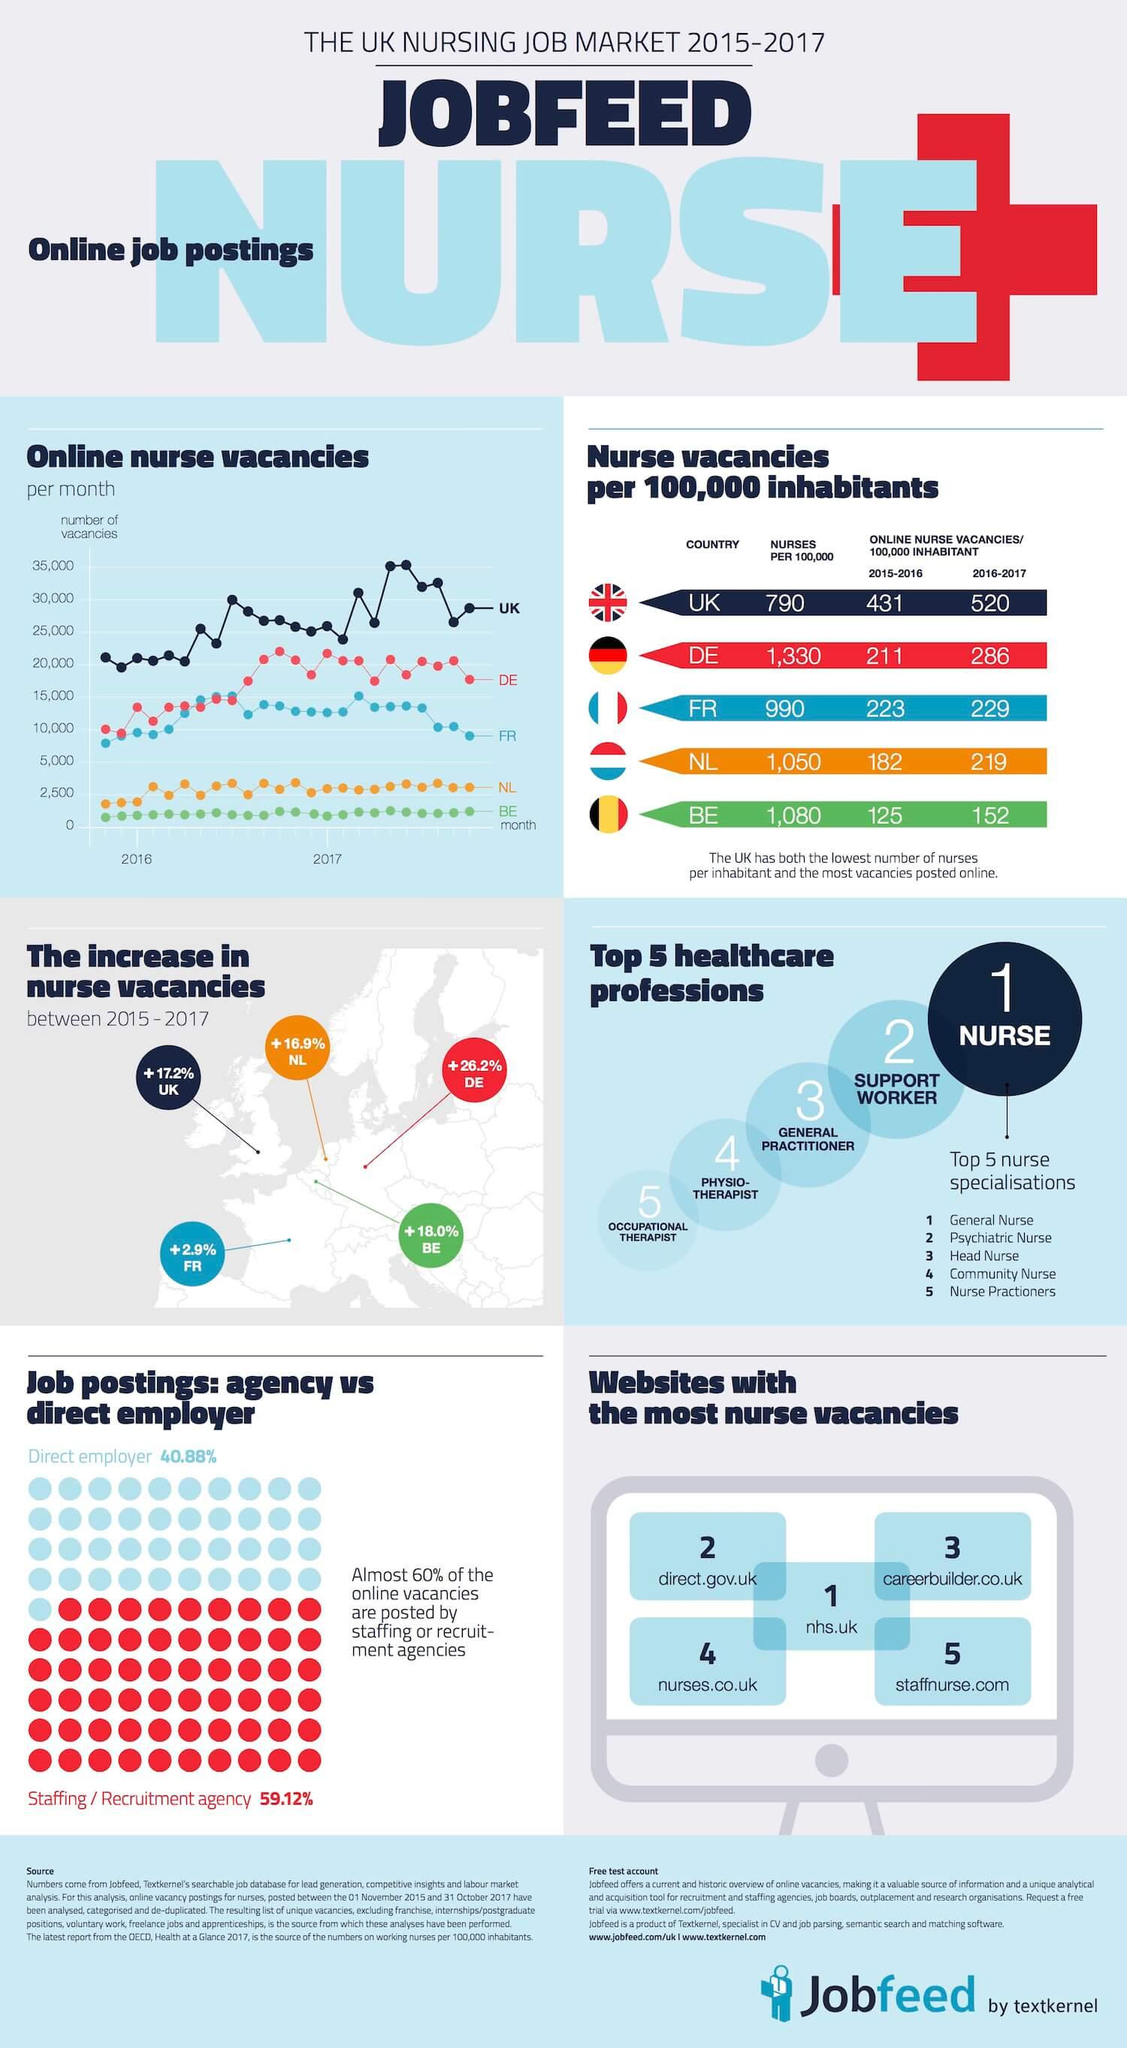Highlight a few significant elements in this photo. According to a recent survey, only 60% of online job vacancies are posted by staffing or recruitment agencies, while 40% are posted directly by the companies themselves. In 2017, the number of vacancies in the UK reached 35,000. The website with the domain name "staffnurse.com" does not contain the string ".uk" in its URL. Five country flags are displayed under the category 'Nurse vacancies per 100,000 inhabitants.' France had the lowest percentage increase in nurse vacancies between 2015 and 2017, according to data. 